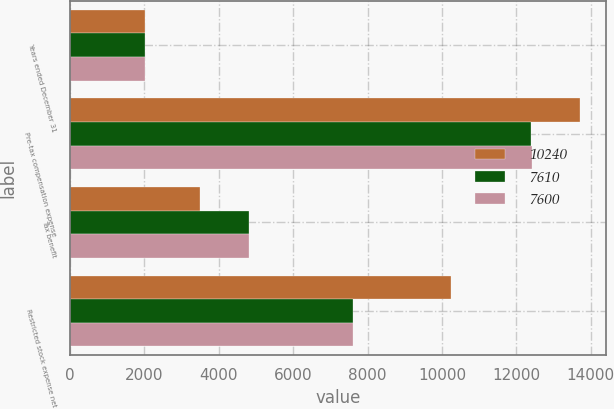Convert chart. <chart><loc_0><loc_0><loc_500><loc_500><stacked_bar_chart><ecel><fcel>Years ended December 31<fcel>Pre-tax compensation expense<fcel>Tax benefit<fcel>Restricted stock expense net<nl><fcel>10240<fcel>2018<fcel>13726<fcel>3486<fcel>10240<nl><fcel>7610<fcel>2017<fcel>12399<fcel>4799<fcel>7600<nl><fcel>7600<fcel>2016<fcel>12415<fcel>4805<fcel>7610<nl></chart> 